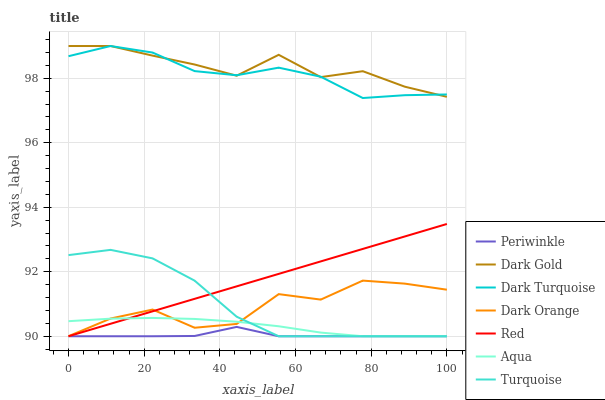Does Turquoise have the minimum area under the curve?
Answer yes or no. No. Does Turquoise have the maximum area under the curve?
Answer yes or no. No. Is Turquoise the smoothest?
Answer yes or no. No. Is Turquoise the roughest?
Answer yes or no. No. Does Dark Gold have the lowest value?
Answer yes or no. No. Does Turquoise have the highest value?
Answer yes or no. No. Is Periwinkle less than Dark Turquoise?
Answer yes or no. Yes. Is Dark Turquoise greater than Dark Orange?
Answer yes or no. Yes. Does Periwinkle intersect Dark Turquoise?
Answer yes or no. No. 